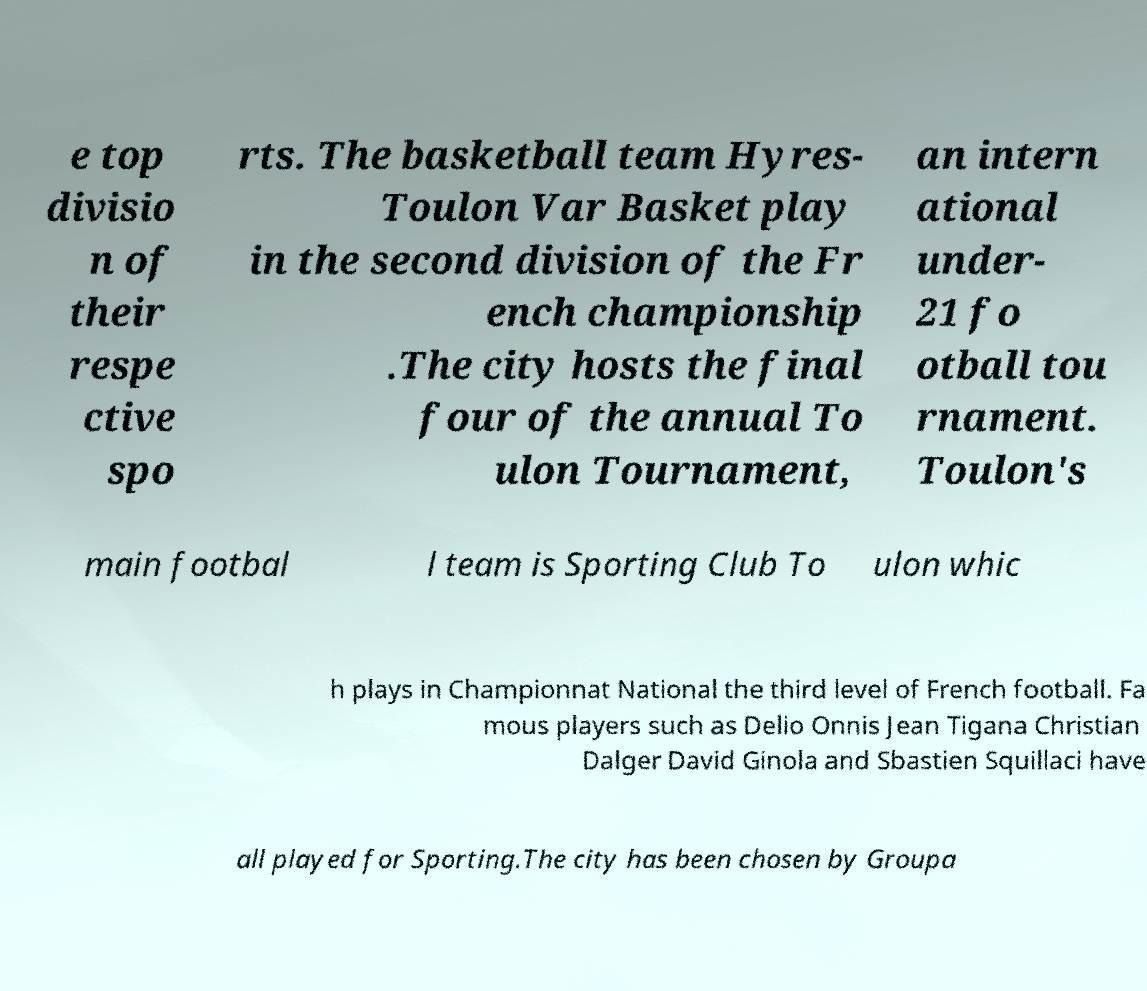Please identify and transcribe the text found in this image. e top divisio n of their respe ctive spo rts. The basketball team Hyres- Toulon Var Basket play in the second division of the Fr ench championship .The city hosts the final four of the annual To ulon Tournament, an intern ational under- 21 fo otball tou rnament. Toulon's main footbal l team is Sporting Club To ulon whic h plays in Championnat National the third level of French football. Fa mous players such as Delio Onnis Jean Tigana Christian Dalger David Ginola and Sbastien Squillaci have all played for Sporting.The city has been chosen by Groupa 